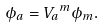<formula> <loc_0><loc_0><loc_500><loc_500>\phi _ { a } = { V _ { a } } ^ { m } \phi _ { m } .</formula> 